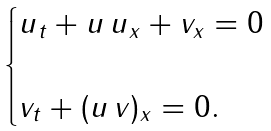<formula> <loc_0><loc_0><loc_500><loc_500>\begin{cases} u _ { t } + u \, u _ { x } + v _ { x } = 0 \\ \\ v _ { t } + ( u \, v ) _ { x } = 0 . \end{cases}</formula> 